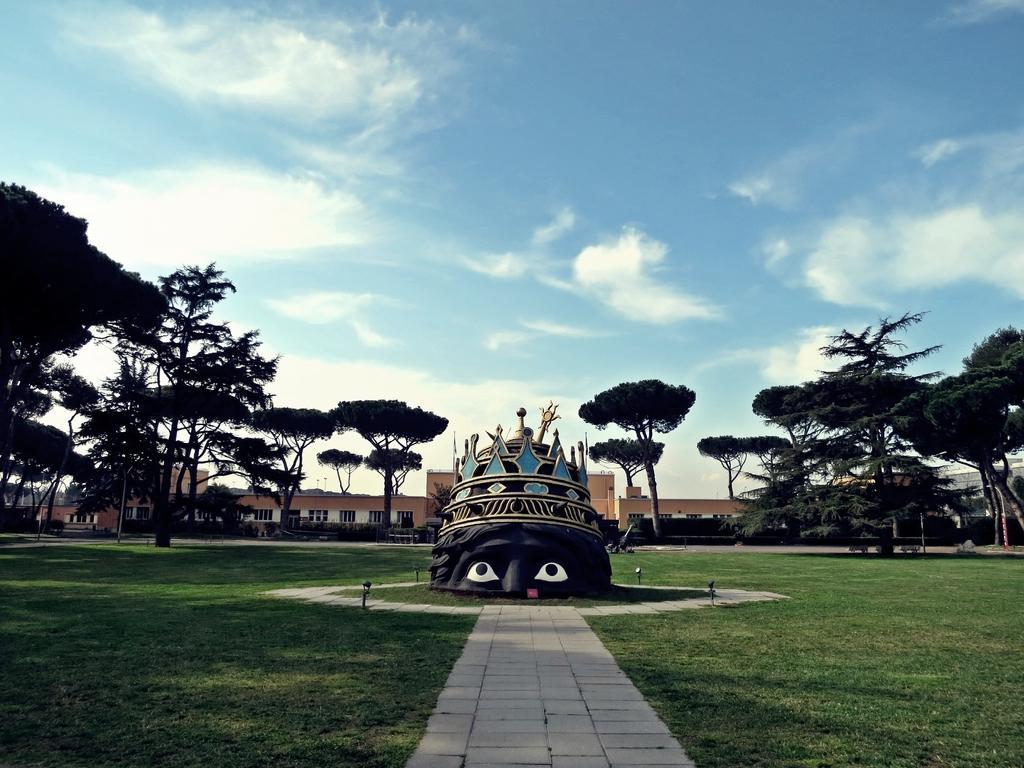How would you summarize this image in a sentence or two? In the center of the image there is a structure, behind the structure, there are trees and buildings, at the top of the image there are clouds in the sky. 